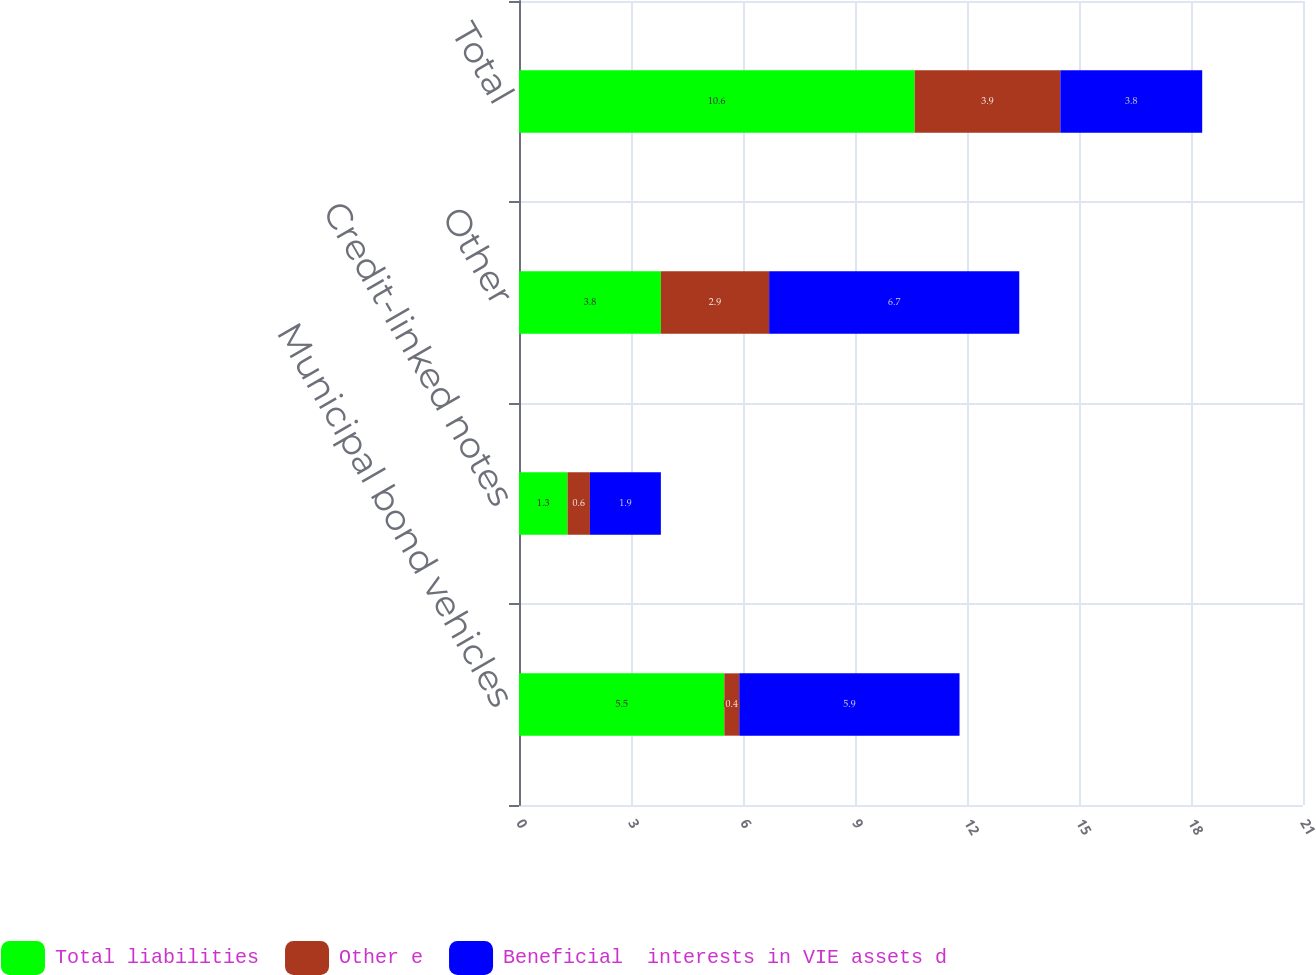Convert chart to OTSL. <chart><loc_0><loc_0><loc_500><loc_500><stacked_bar_chart><ecel><fcel>Municipal bond vehicles<fcel>Credit-linked notes<fcel>Other<fcel>Total<nl><fcel>Total liabilities<fcel>5.5<fcel>1.3<fcel>3.8<fcel>10.6<nl><fcel>Other e<fcel>0.4<fcel>0.6<fcel>2.9<fcel>3.9<nl><fcel>Beneficial  interests in VIE assets d<fcel>5.9<fcel>1.9<fcel>6.7<fcel>3.8<nl></chart> 